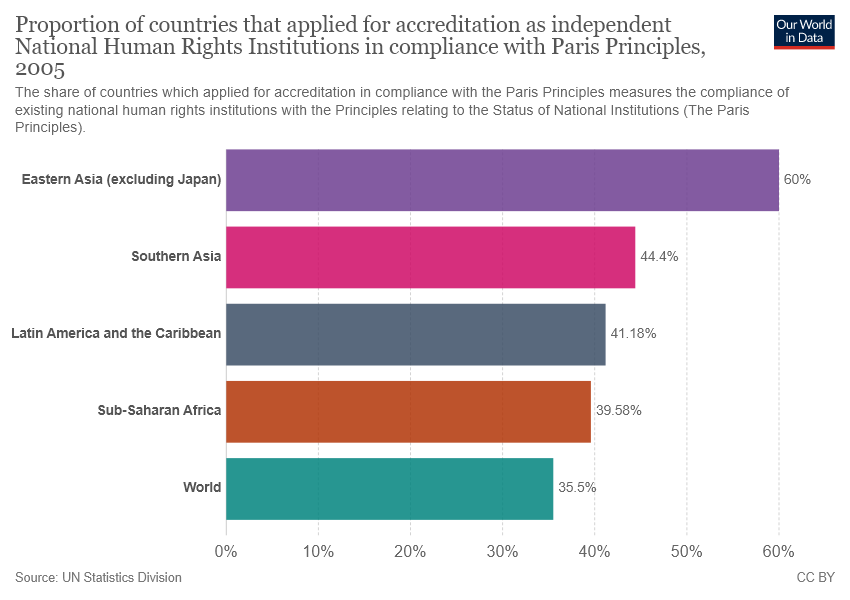Specify some key components in this picture. The second largest value in the graph is 0.444... Find the average of the values below 40: the result is 0.3754. 